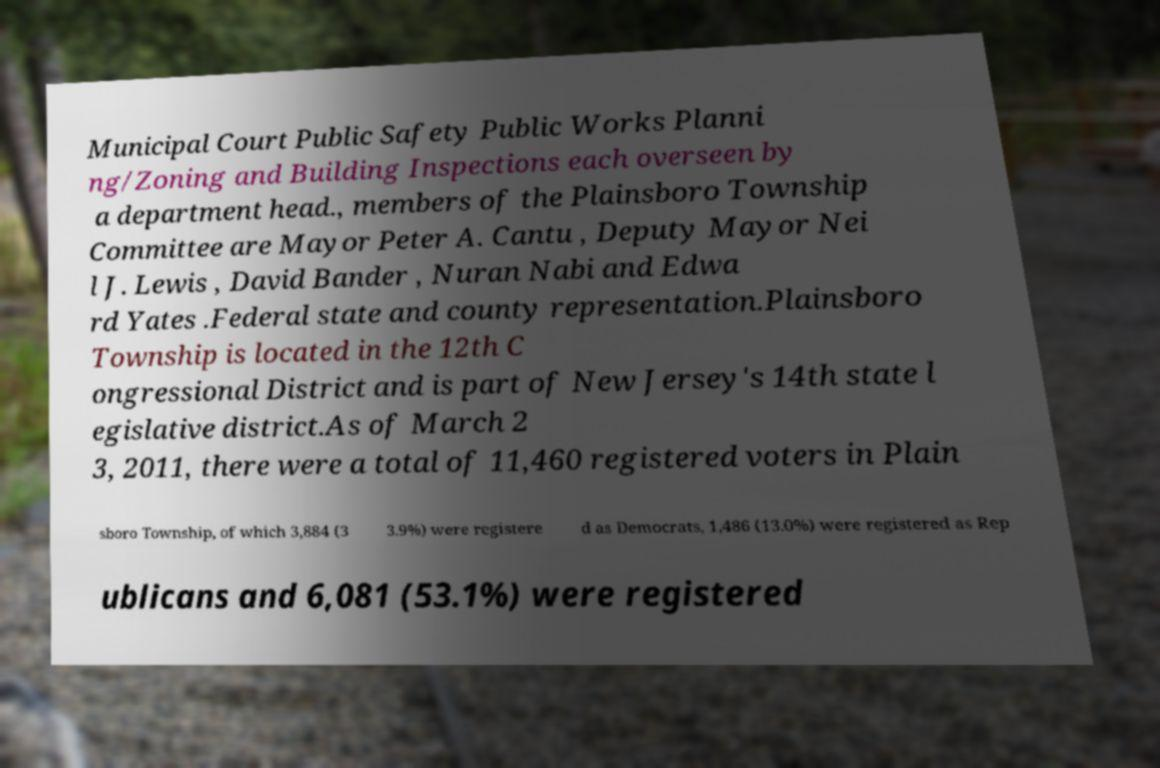For documentation purposes, I need the text within this image transcribed. Could you provide that? Municipal Court Public Safety Public Works Planni ng/Zoning and Building Inspections each overseen by a department head., members of the Plainsboro Township Committee are Mayor Peter A. Cantu , Deputy Mayor Nei l J. Lewis , David Bander , Nuran Nabi and Edwa rd Yates .Federal state and county representation.Plainsboro Township is located in the 12th C ongressional District and is part of New Jersey's 14th state l egislative district.As of March 2 3, 2011, there were a total of 11,460 registered voters in Plain sboro Township, of which 3,884 (3 3.9%) were registere d as Democrats, 1,486 (13.0%) were registered as Rep ublicans and 6,081 (53.1%) were registered 